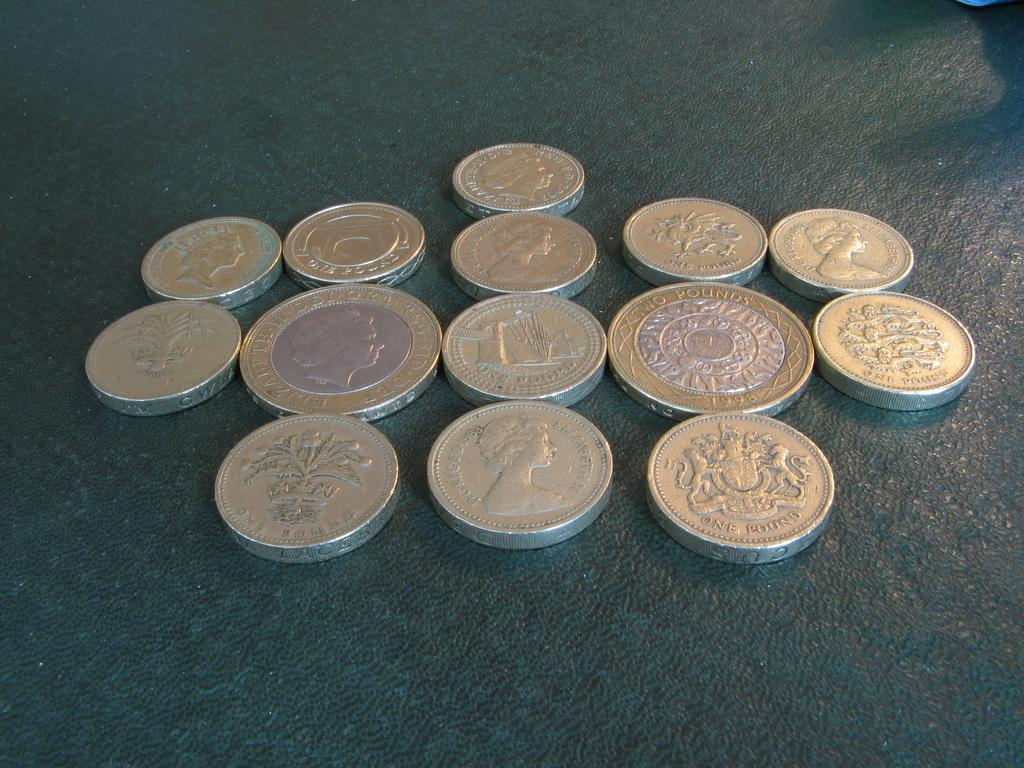Provide a one-sentence caption for the provided image. Several British Pounds are laying on a table. 